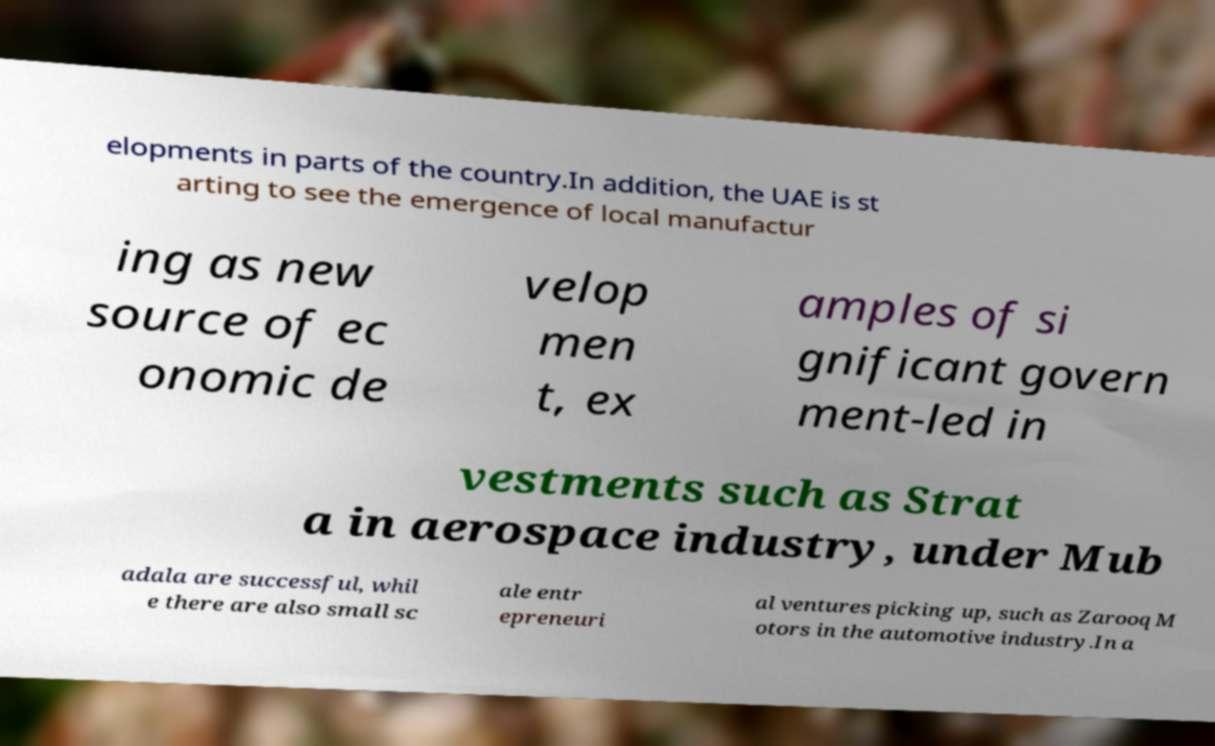Could you assist in decoding the text presented in this image and type it out clearly? elopments in parts of the country.In addition, the UAE is st arting to see the emergence of local manufactur ing as new source of ec onomic de velop men t, ex amples of si gnificant govern ment-led in vestments such as Strat a in aerospace industry, under Mub adala are successful, whil e there are also small sc ale entr epreneuri al ventures picking up, such as Zarooq M otors in the automotive industry.In a 